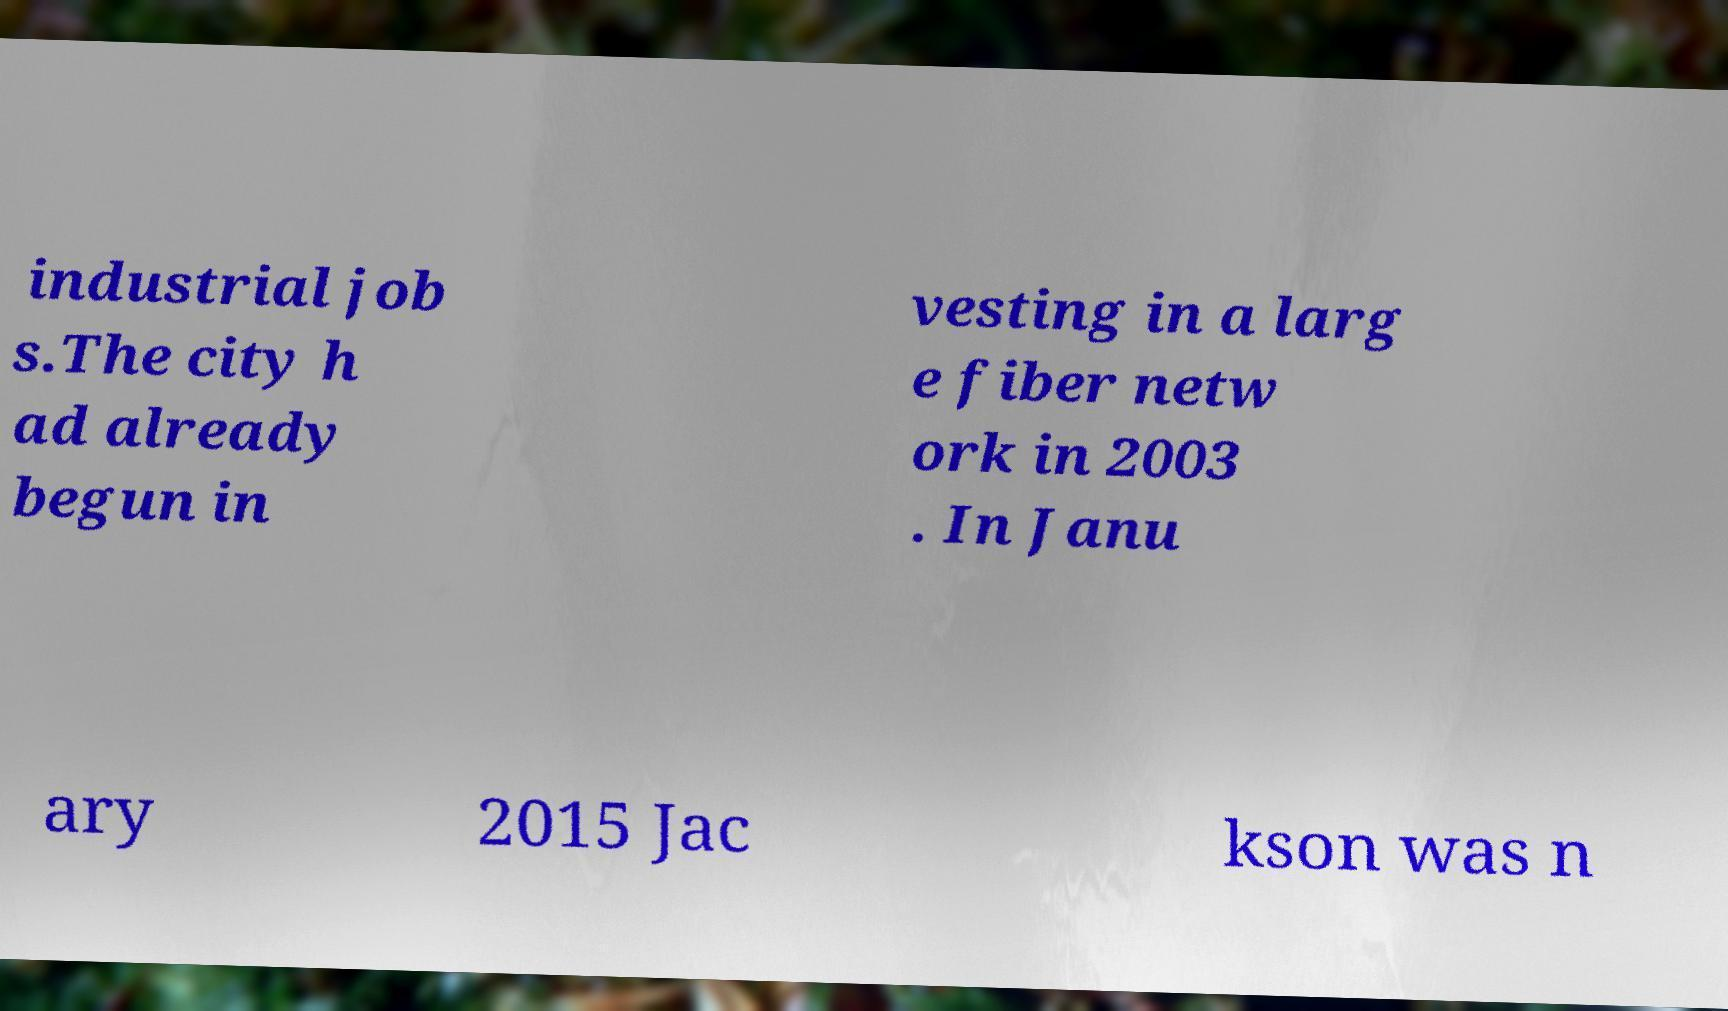Could you assist in decoding the text presented in this image and type it out clearly? industrial job s.The city h ad already begun in vesting in a larg e fiber netw ork in 2003 . In Janu ary 2015 Jac kson was n 